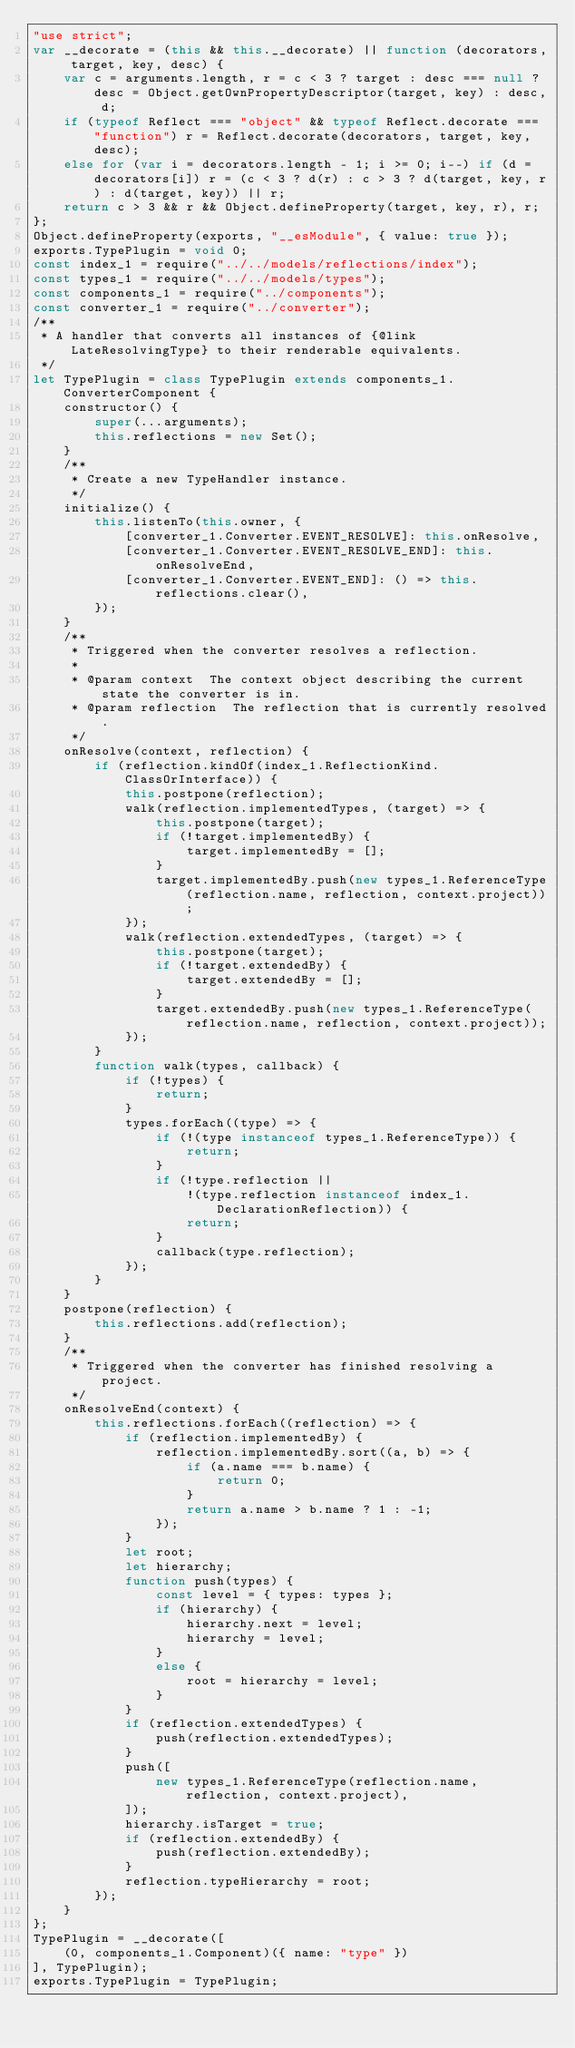<code> <loc_0><loc_0><loc_500><loc_500><_JavaScript_>"use strict";
var __decorate = (this && this.__decorate) || function (decorators, target, key, desc) {
    var c = arguments.length, r = c < 3 ? target : desc === null ? desc = Object.getOwnPropertyDescriptor(target, key) : desc, d;
    if (typeof Reflect === "object" && typeof Reflect.decorate === "function") r = Reflect.decorate(decorators, target, key, desc);
    else for (var i = decorators.length - 1; i >= 0; i--) if (d = decorators[i]) r = (c < 3 ? d(r) : c > 3 ? d(target, key, r) : d(target, key)) || r;
    return c > 3 && r && Object.defineProperty(target, key, r), r;
};
Object.defineProperty(exports, "__esModule", { value: true });
exports.TypePlugin = void 0;
const index_1 = require("../../models/reflections/index");
const types_1 = require("../../models/types");
const components_1 = require("../components");
const converter_1 = require("../converter");
/**
 * A handler that converts all instances of {@link LateResolvingType} to their renderable equivalents.
 */
let TypePlugin = class TypePlugin extends components_1.ConverterComponent {
    constructor() {
        super(...arguments);
        this.reflections = new Set();
    }
    /**
     * Create a new TypeHandler instance.
     */
    initialize() {
        this.listenTo(this.owner, {
            [converter_1.Converter.EVENT_RESOLVE]: this.onResolve,
            [converter_1.Converter.EVENT_RESOLVE_END]: this.onResolveEnd,
            [converter_1.Converter.EVENT_END]: () => this.reflections.clear(),
        });
    }
    /**
     * Triggered when the converter resolves a reflection.
     *
     * @param context  The context object describing the current state the converter is in.
     * @param reflection  The reflection that is currently resolved.
     */
    onResolve(context, reflection) {
        if (reflection.kindOf(index_1.ReflectionKind.ClassOrInterface)) {
            this.postpone(reflection);
            walk(reflection.implementedTypes, (target) => {
                this.postpone(target);
                if (!target.implementedBy) {
                    target.implementedBy = [];
                }
                target.implementedBy.push(new types_1.ReferenceType(reflection.name, reflection, context.project));
            });
            walk(reflection.extendedTypes, (target) => {
                this.postpone(target);
                if (!target.extendedBy) {
                    target.extendedBy = [];
                }
                target.extendedBy.push(new types_1.ReferenceType(reflection.name, reflection, context.project));
            });
        }
        function walk(types, callback) {
            if (!types) {
                return;
            }
            types.forEach((type) => {
                if (!(type instanceof types_1.ReferenceType)) {
                    return;
                }
                if (!type.reflection ||
                    !(type.reflection instanceof index_1.DeclarationReflection)) {
                    return;
                }
                callback(type.reflection);
            });
        }
    }
    postpone(reflection) {
        this.reflections.add(reflection);
    }
    /**
     * Triggered when the converter has finished resolving a project.
     */
    onResolveEnd(context) {
        this.reflections.forEach((reflection) => {
            if (reflection.implementedBy) {
                reflection.implementedBy.sort((a, b) => {
                    if (a.name === b.name) {
                        return 0;
                    }
                    return a.name > b.name ? 1 : -1;
                });
            }
            let root;
            let hierarchy;
            function push(types) {
                const level = { types: types };
                if (hierarchy) {
                    hierarchy.next = level;
                    hierarchy = level;
                }
                else {
                    root = hierarchy = level;
                }
            }
            if (reflection.extendedTypes) {
                push(reflection.extendedTypes);
            }
            push([
                new types_1.ReferenceType(reflection.name, reflection, context.project),
            ]);
            hierarchy.isTarget = true;
            if (reflection.extendedBy) {
                push(reflection.extendedBy);
            }
            reflection.typeHierarchy = root;
        });
    }
};
TypePlugin = __decorate([
    (0, components_1.Component)({ name: "type" })
], TypePlugin);
exports.TypePlugin = TypePlugin;
</code> 